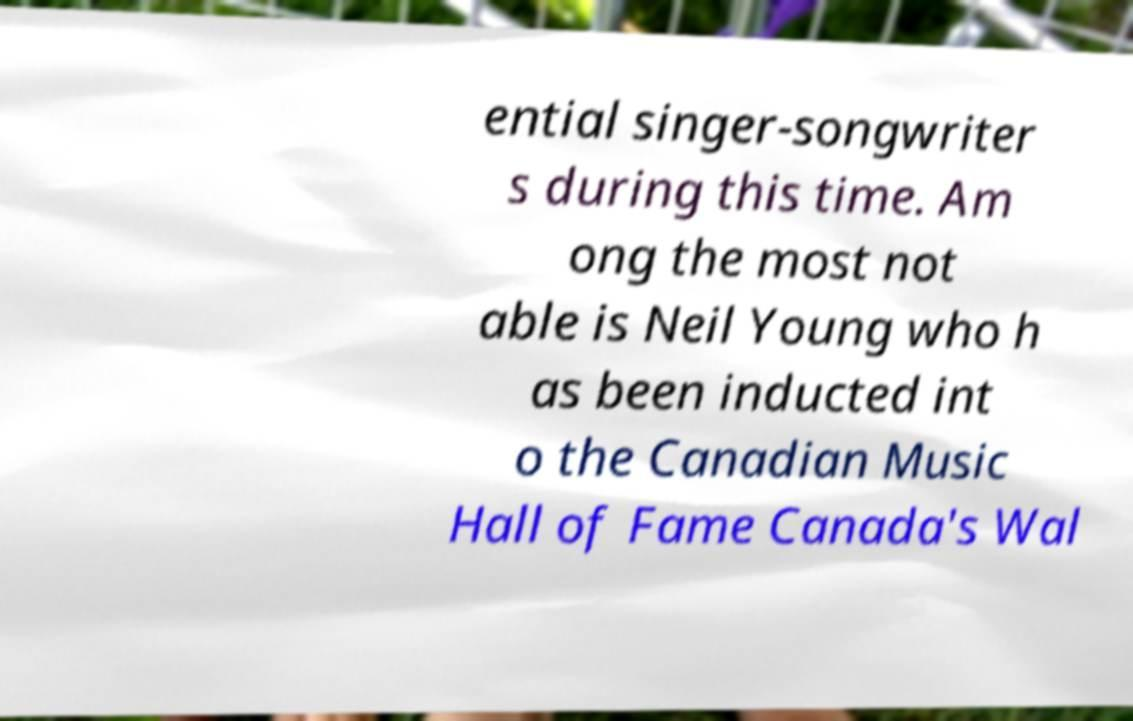Please read and relay the text visible in this image. What does it say? ential singer-songwriter s during this time. Am ong the most not able is Neil Young who h as been inducted int o the Canadian Music Hall of Fame Canada's Wal 